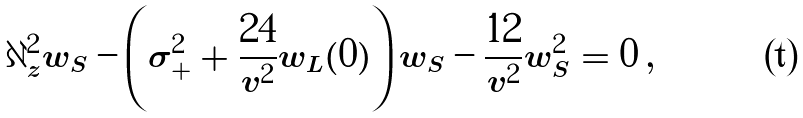<formula> <loc_0><loc_0><loc_500><loc_500>\partial ^ { 2 } _ { z } w _ { S } - \left ( \sigma ^ { 2 } _ { + } + \frac { 2 4 } { v ^ { 2 } } w _ { L } ( 0 ) \right ) w _ { S } - \frac { 1 2 } { v ^ { 2 } } w ^ { 2 } _ { S } = 0 \, ,</formula> 